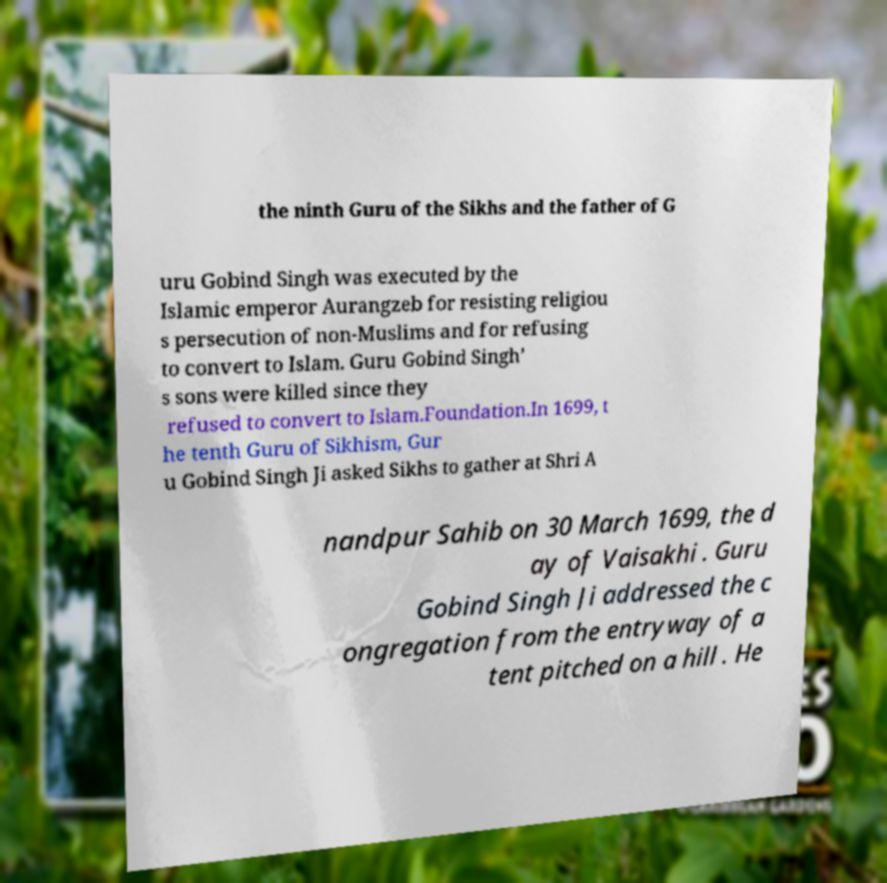Can you read and provide the text displayed in the image?This photo seems to have some interesting text. Can you extract and type it out for me? the ninth Guru of the Sikhs and the father of G uru Gobind Singh was executed by the Islamic emperor Aurangzeb for resisting religiou s persecution of non-Muslims and for refusing to convert to Islam. Guru Gobind Singh’ s sons were killed since they refused to convert to Islam.Foundation.In 1699, t he tenth Guru of Sikhism, Gur u Gobind Singh Ji asked Sikhs to gather at Shri A nandpur Sahib on 30 March 1699, the d ay of Vaisakhi . Guru Gobind Singh Ji addressed the c ongregation from the entryway of a tent pitched on a hill . He 